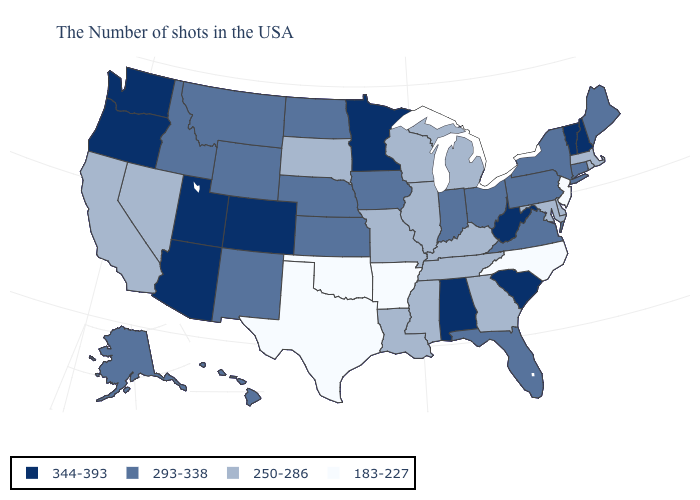Which states hav the highest value in the MidWest?
Give a very brief answer. Minnesota. What is the highest value in the USA?
Be succinct. 344-393. What is the value of Colorado?
Concise answer only. 344-393. Name the states that have a value in the range 250-286?
Give a very brief answer. Massachusetts, Rhode Island, Delaware, Maryland, Georgia, Michigan, Kentucky, Tennessee, Wisconsin, Illinois, Mississippi, Louisiana, Missouri, South Dakota, Nevada, California. Name the states that have a value in the range 250-286?
Short answer required. Massachusetts, Rhode Island, Delaware, Maryland, Georgia, Michigan, Kentucky, Tennessee, Wisconsin, Illinois, Mississippi, Louisiana, Missouri, South Dakota, Nevada, California. Name the states that have a value in the range 183-227?
Write a very short answer. New Jersey, North Carolina, Arkansas, Oklahoma, Texas. Among the states that border Tennessee , which have the highest value?
Quick response, please. Alabama. What is the highest value in the MidWest ?
Short answer required. 344-393. What is the value of Maine?
Answer briefly. 293-338. What is the value of Idaho?
Be succinct. 293-338. What is the lowest value in the West?
Answer briefly. 250-286. What is the value of South Dakota?
Give a very brief answer. 250-286. Name the states that have a value in the range 250-286?
Answer briefly. Massachusetts, Rhode Island, Delaware, Maryland, Georgia, Michigan, Kentucky, Tennessee, Wisconsin, Illinois, Mississippi, Louisiana, Missouri, South Dakota, Nevada, California. Name the states that have a value in the range 183-227?
Short answer required. New Jersey, North Carolina, Arkansas, Oklahoma, Texas. Name the states that have a value in the range 293-338?
Quick response, please. Maine, Connecticut, New York, Pennsylvania, Virginia, Ohio, Florida, Indiana, Iowa, Kansas, Nebraska, North Dakota, Wyoming, New Mexico, Montana, Idaho, Alaska, Hawaii. 